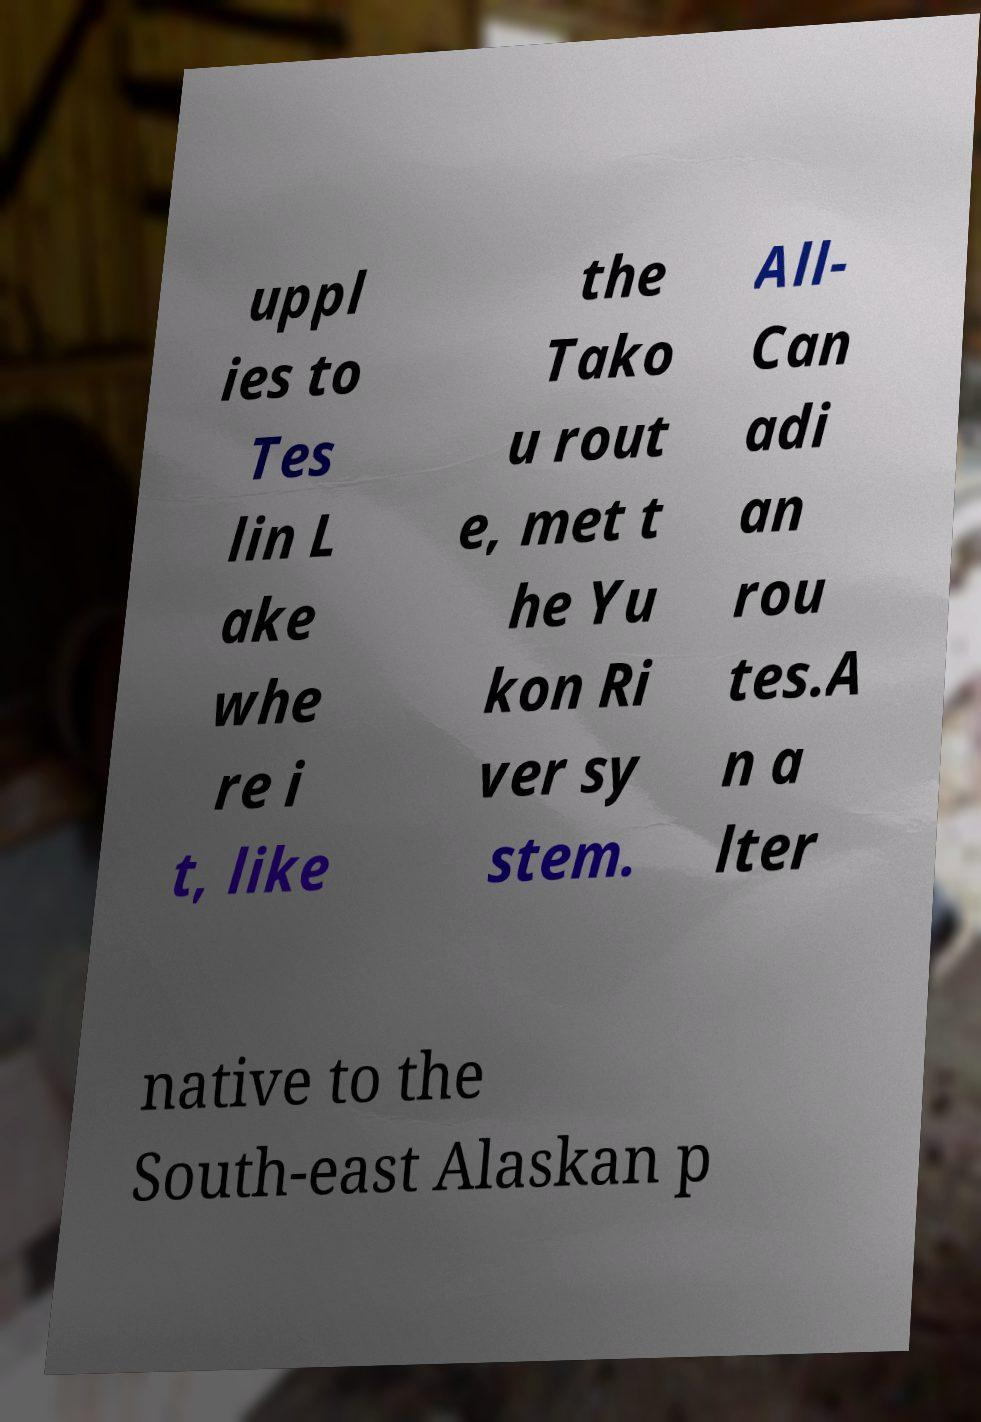Could you extract and type out the text from this image? uppl ies to Tes lin L ake whe re i t, like the Tako u rout e, met t he Yu kon Ri ver sy stem. All- Can adi an rou tes.A n a lter native to the South-east Alaskan p 